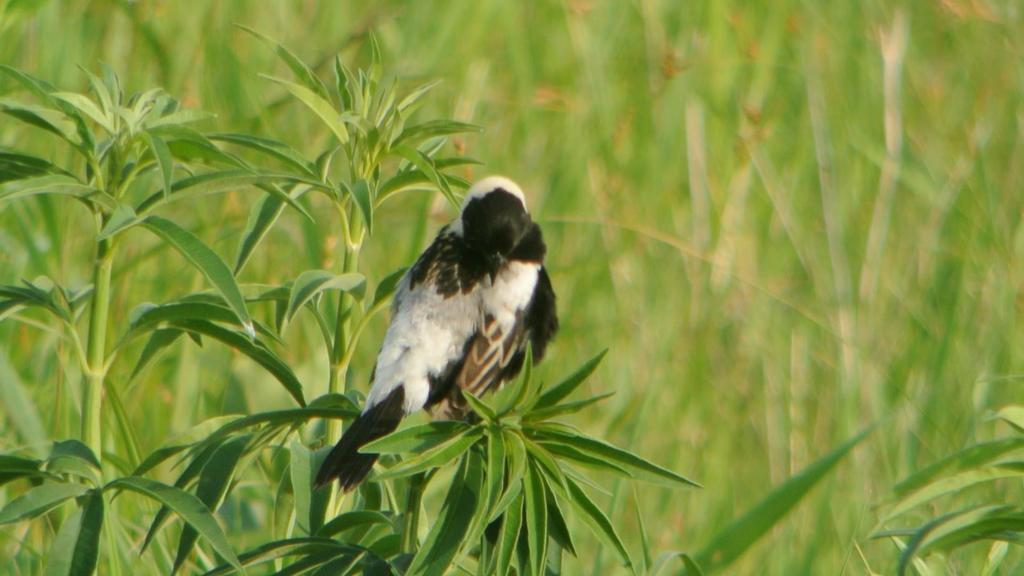What type of animal is in the image? There is a bird in the image. Where is the bird located? The bird is on a plant. Can you describe the background of the image? The background of the image is blurred. What type of badge is the bird wearing in the image? There is no badge present in the image; the bird is simply perched on a plant. 